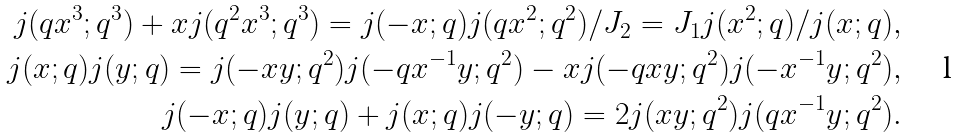<formula> <loc_0><loc_0><loc_500><loc_500>j ( q x ^ { 3 } ; q ^ { 3 } ) + x j ( q ^ { 2 } x ^ { 3 } ; q ^ { 3 } ) = j ( - x ; q ) j ( q x ^ { 2 } ; q ^ { 2 } ) / J _ { 2 } = { J _ { 1 } j ( x ^ { 2 } ; q ) } / { j ( x ; q ) } , \\ j ( x ; q ) j ( y ; q ) = j ( - x y ; q ^ { 2 } ) j ( - q x ^ { - 1 } y ; q ^ { 2 } ) - x j ( - q x y ; q ^ { 2 } ) j ( - x ^ { - 1 } y ; q ^ { 2 } ) , \\ j ( - x ; q ) j ( y ; q ) + j ( x ; q ) j ( - y ; q ) = 2 j ( x y ; q ^ { 2 } ) j ( q x ^ { - 1 } y ; q ^ { 2 } ) .</formula> 